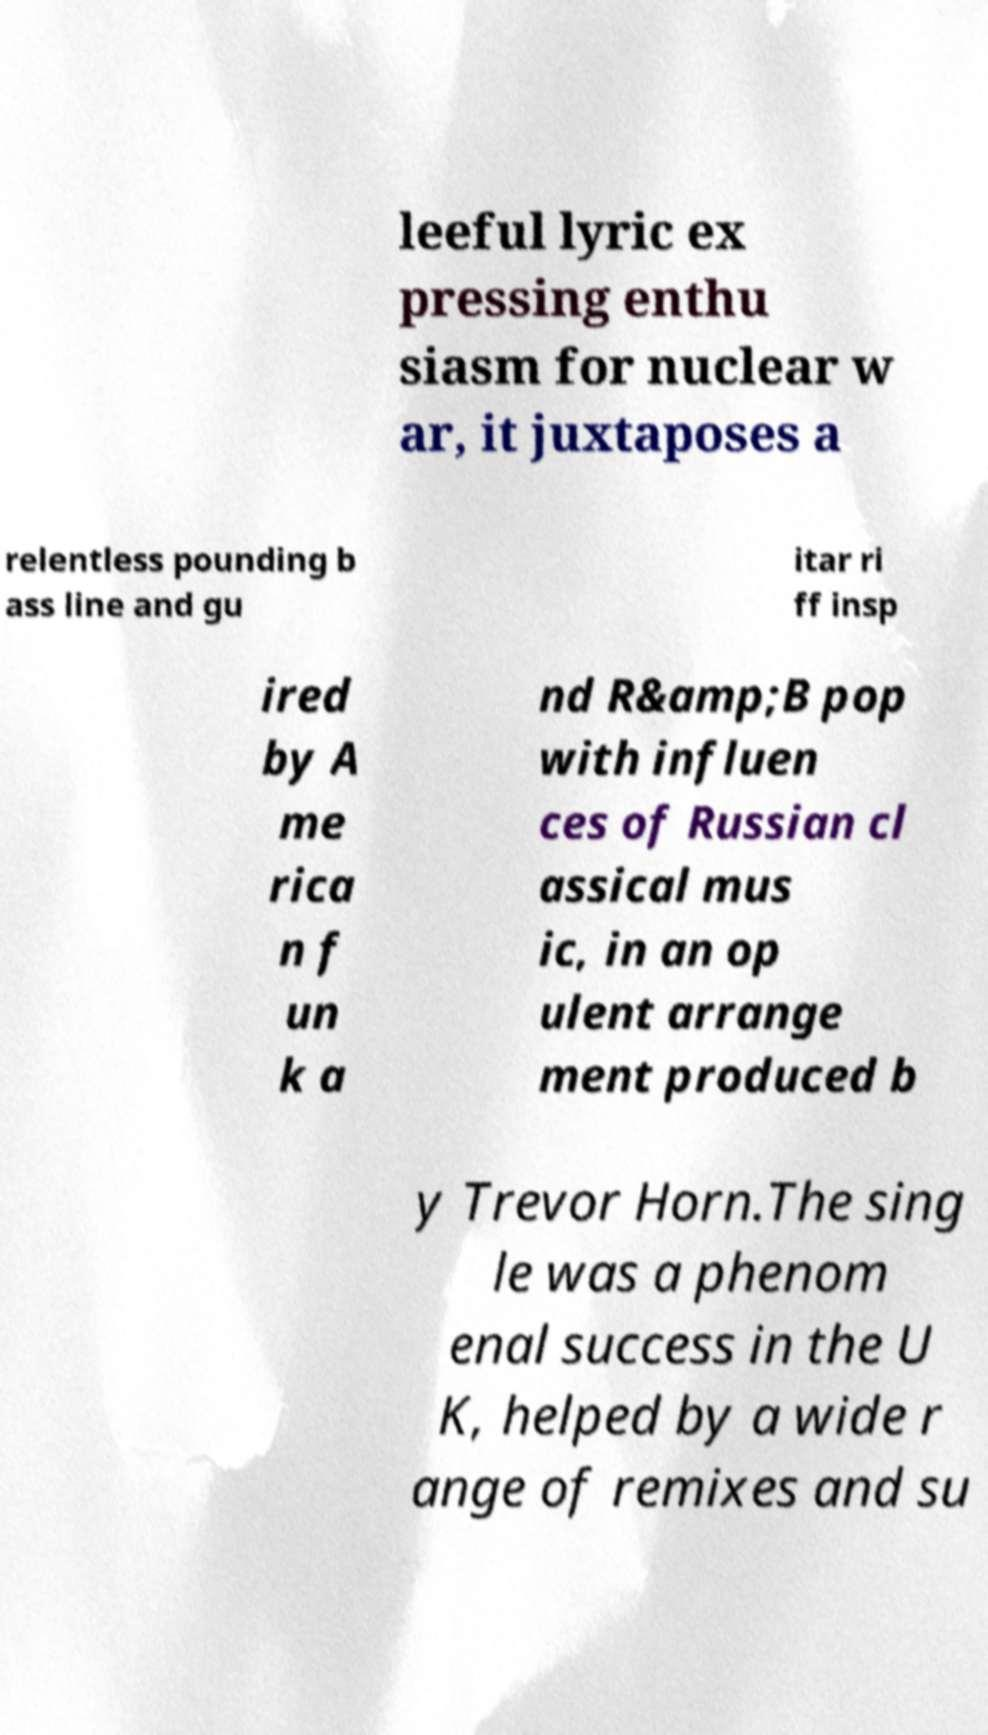Please identify and transcribe the text found in this image. leeful lyric ex pressing enthu siasm for nuclear w ar, it juxtaposes a relentless pounding b ass line and gu itar ri ff insp ired by A me rica n f un k a nd R&amp;B pop with influen ces of Russian cl assical mus ic, in an op ulent arrange ment produced b y Trevor Horn.The sing le was a phenom enal success in the U K, helped by a wide r ange of remixes and su 